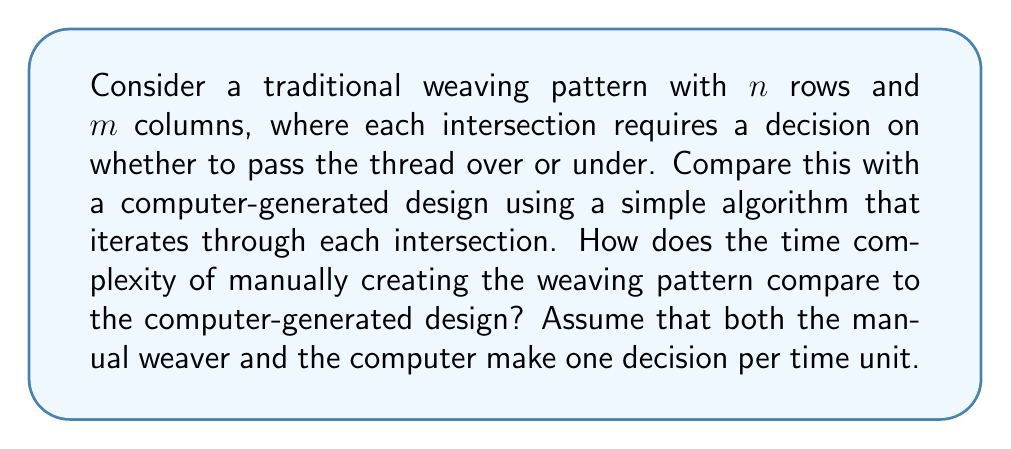Give your solution to this math problem. To analyze this problem, let's break it down step-by-step:

1. Manual weaving process:
   - The weaver must make a decision for each intersection in the pattern.
   - Total number of intersections = $n \times m$
   - Each decision takes one time unit.
   - Therefore, the time complexity for manual weaving is $O(nm)$.

2. Computer-generated design:
   - The computer also needs to make a decision for each intersection.
   - It uses a simple iterative algorithm to go through all intersections.
   - The algorithm can be represented as nested loops:
     ```
     for i = 1 to n:
         for j = 1 to m:
             make_decision(i, j)
     ```
   - This results in $n \times m$ operations.
   - Each operation (decision) takes one time unit.
   - The time complexity for the computer-generated design is also $O(nm)$.

3. Comparison:
   - Both processes have the same time complexity of $O(nm)$.
   - This means that, theoretically, they scale similarly as the size of the pattern increases.

4. Practical considerations:
   - While the time complexity is the same, the actual time taken may differ:
     - A skilled weaver might make decisions faster for familiar patterns.
     - The computer can typically process intersections much faster than a human.
   - The computer's advantage grows as the pattern size increases.

5. Cultural perspective:
   - From the viewpoint of a young indigenous woman skeptical of technology:
     - The equal time complexity might suggest that traditional methods are just as "efficient" in theory.
     - However, the cultural and artistic value of manual weaving goes beyond mere time considerations.
     - The process of manual weaving involves cultural knowledge, skill development, and personal expression that a computer algorithm cannot replicate.
Answer: The time complexity for both manual weaving and the computer-generated design is $O(nm)$, where $n$ is the number of rows and $m$ is the number of columns in the pattern. While theoretically equivalent in terms of time complexity, practical speed differences and cultural considerations make this comparison more nuanced in real-world applications. 